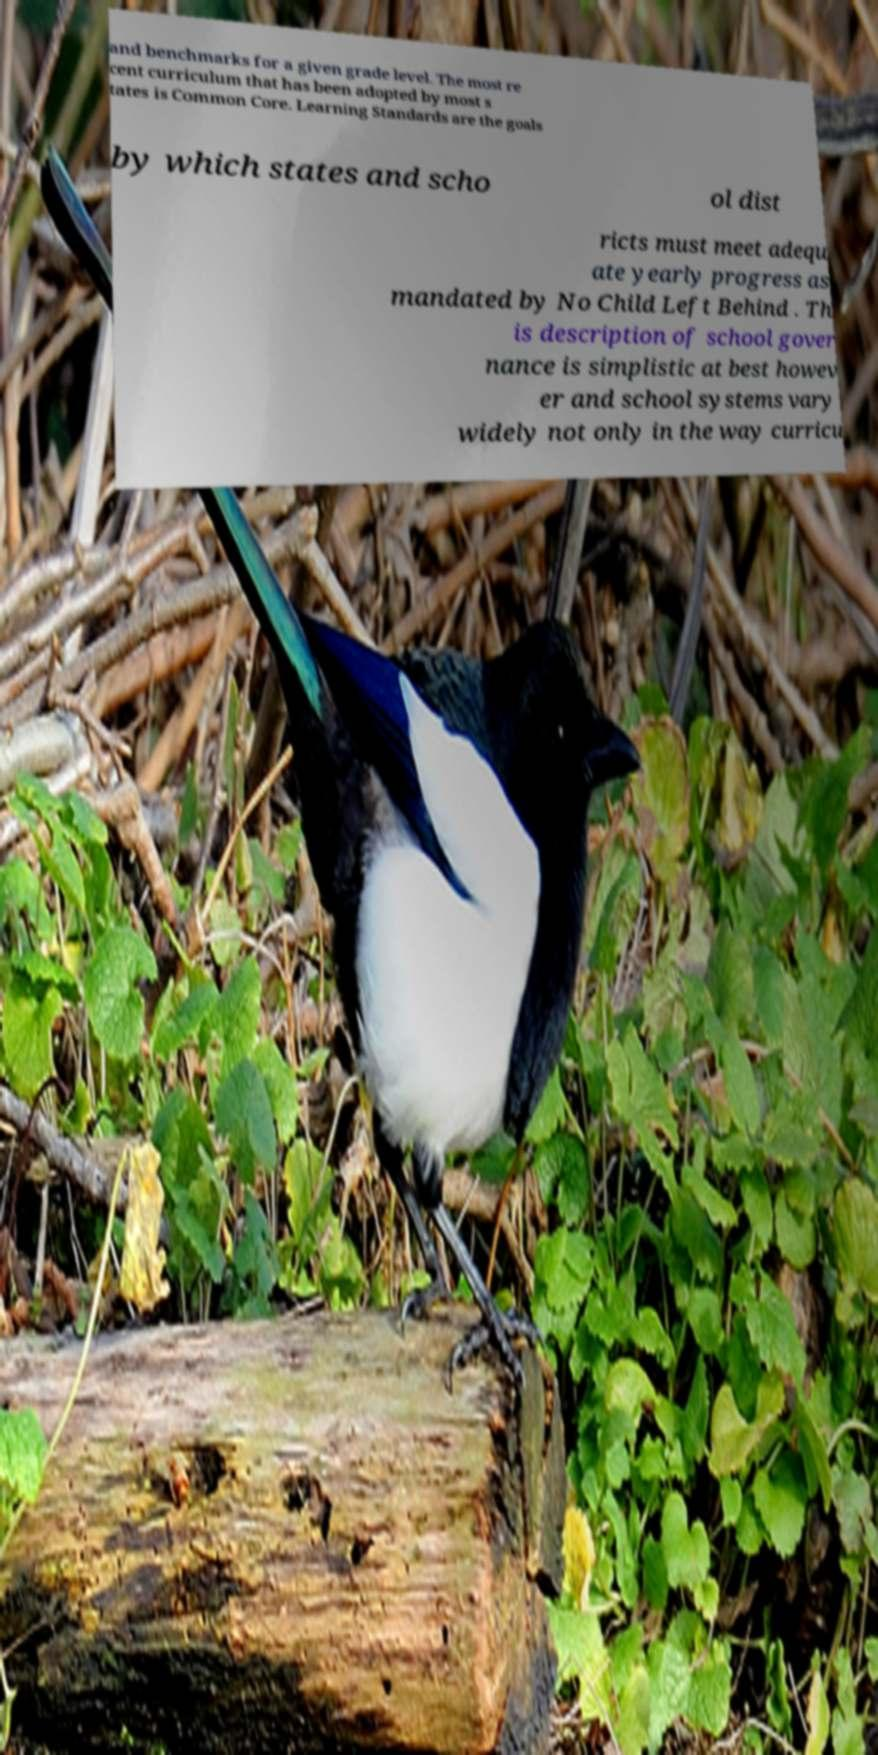Could you assist in decoding the text presented in this image and type it out clearly? and benchmarks for a given grade level. The most re cent curriculum that has been adopted by most s tates is Common Core. Learning Standards are the goals by which states and scho ol dist ricts must meet adequ ate yearly progress as mandated by No Child Left Behind . Th is description of school gover nance is simplistic at best howev er and school systems vary widely not only in the way curricu 